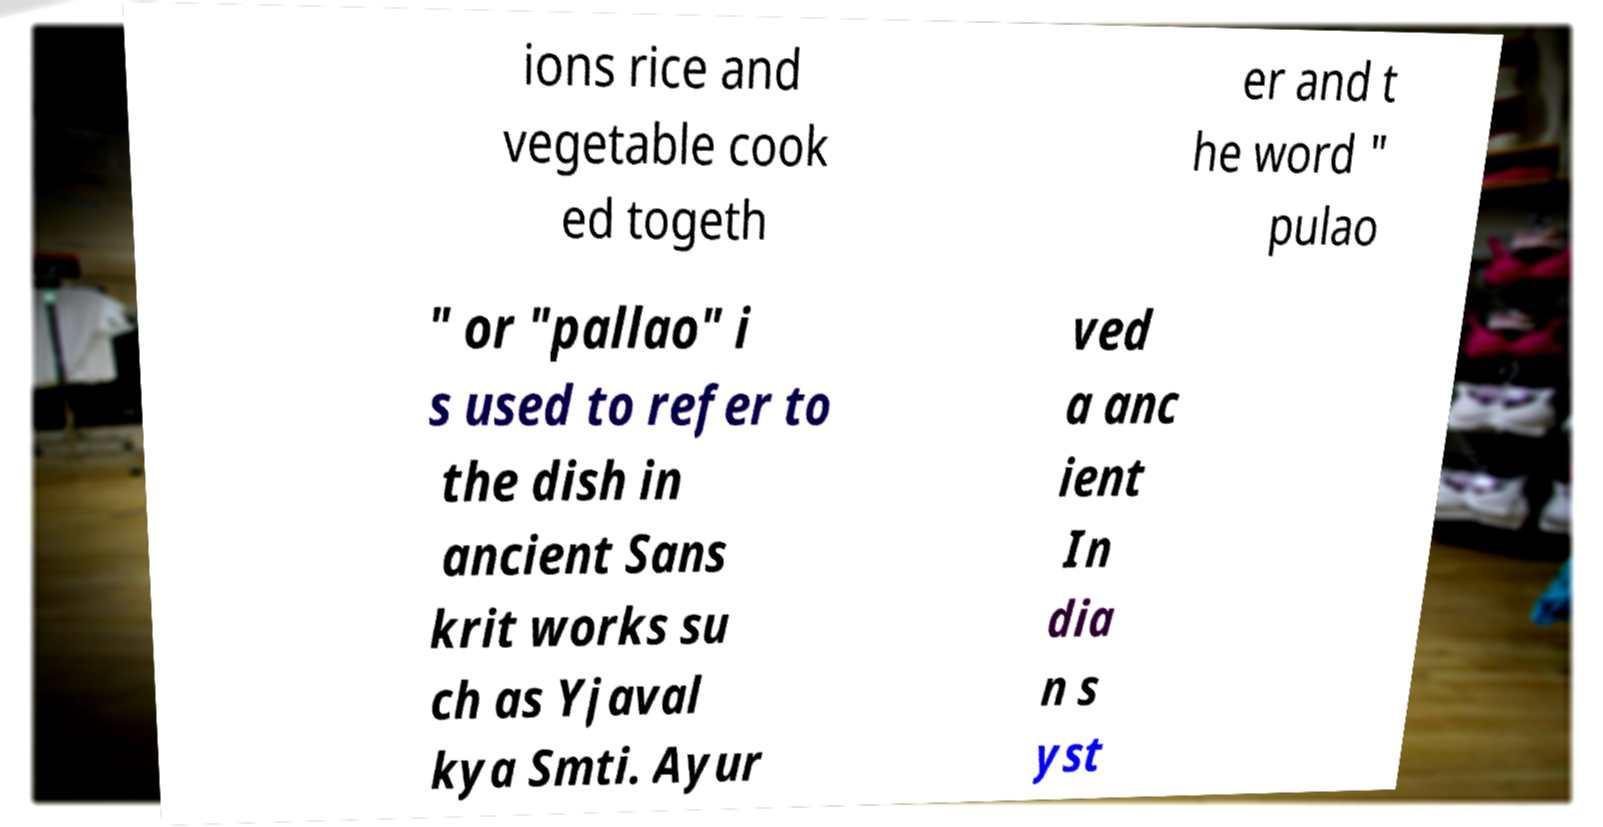Please read and relay the text visible in this image. What does it say? ions rice and vegetable cook ed togeth er and t he word " pulao " or "pallao" i s used to refer to the dish in ancient Sans krit works su ch as Yjaval kya Smti. Ayur ved a anc ient In dia n s yst 